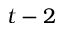<formula> <loc_0><loc_0><loc_500><loc_500>t - 2</formula> 